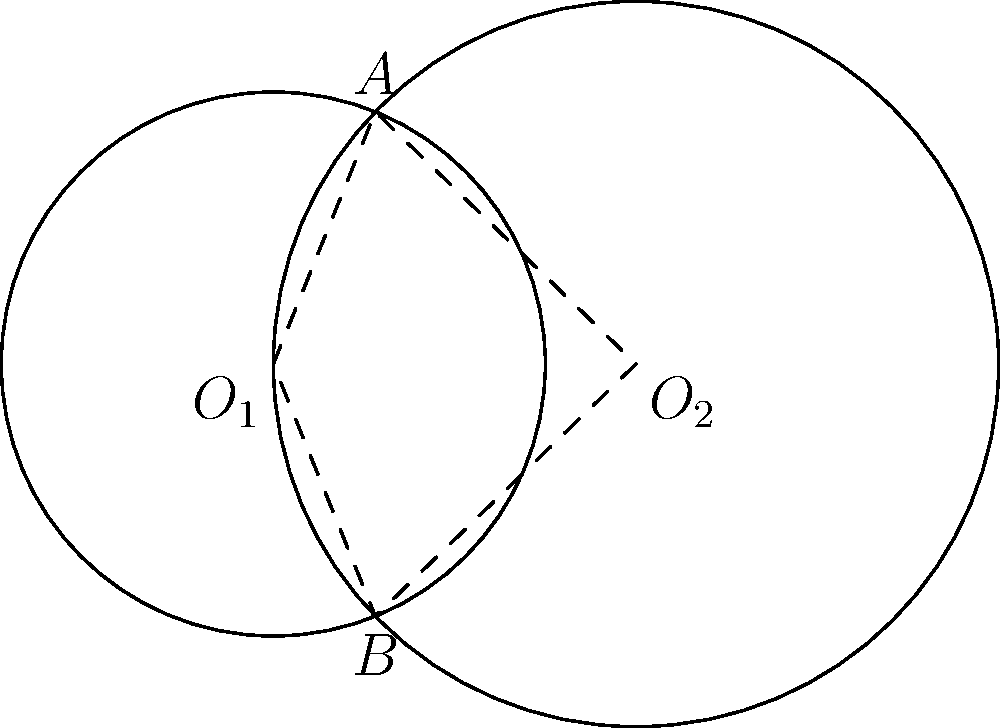In a Raspberry Pi-based robotics project, two circular sensors with radii 3 cm and 4 cm are placed 4 cm apart. The intersection of their detection areas forms a lens-shaped region. Calculate the area of this lens-shaped region to optimize the sensor coverage. Round your answer to two decimal places. Let's approach this step-by-step:

1) First, we need to find the height of the lens. We can do this by calculating the height of the triangle formed by the centers of the circles and one of the intersection points.

2) Let's call the centers $O_1$ and $O_2$, and one of the intersection points $A$. We know that $O_1O_2 = 4$ cm, $O_1A = 3$ cm, and $O_2A = 4$ cm.

3) Using the Pythagorean theorem in triangle $O_1AO_2$:

   $h^2 + 2^2 = 3^2$ (where $h$ is the height of the lens)

4) Solving for $h$:
   $h^2 = 9 - 4 = 5$
   $h = \sqrt{5}$ cm

5) Now we can calculate the area of the lens using the formula:

   $Area = 2(r_1^2 \arccos(\frac{d}{2r_1}) - \frac{d}{2}\sqrt{r_1^2 - \frac{d^2}{4}}) + 2(r_2^2 \arccos(\frac{d}{2r_2}) - \frac{d}{2}\sqrt{r_2^2 - \frac{d^2}{4}})$

   where $r_1 = 3$, $r_2 = 4$, and $d = 4$

6) Plugging in the values:

   $Area = 2(3^2 \arccos(\frac{4}{2(3)}) - \frac{4}{2}\sqrt{3^2 - \frac{4^2}{4}}) + 2(4^2 \arccos(\frac{4}{2(4)}) - \frac{4}{2}\sqrt{4^2 - \frac{4^2}{4}})$

7) Simplifying:

   $Area = 2(9 \arccos(\frac{2}{3}) - 2\sqrt{5}) + 2(16 \arccos(\frac{1}{2}) - 2\sqrt{12})$

8) Calculating:

   $Area \approx 9.31$ cm²

Rounding to two decimal places gives 9.31 cm².
Answer: 9.31 cm² 